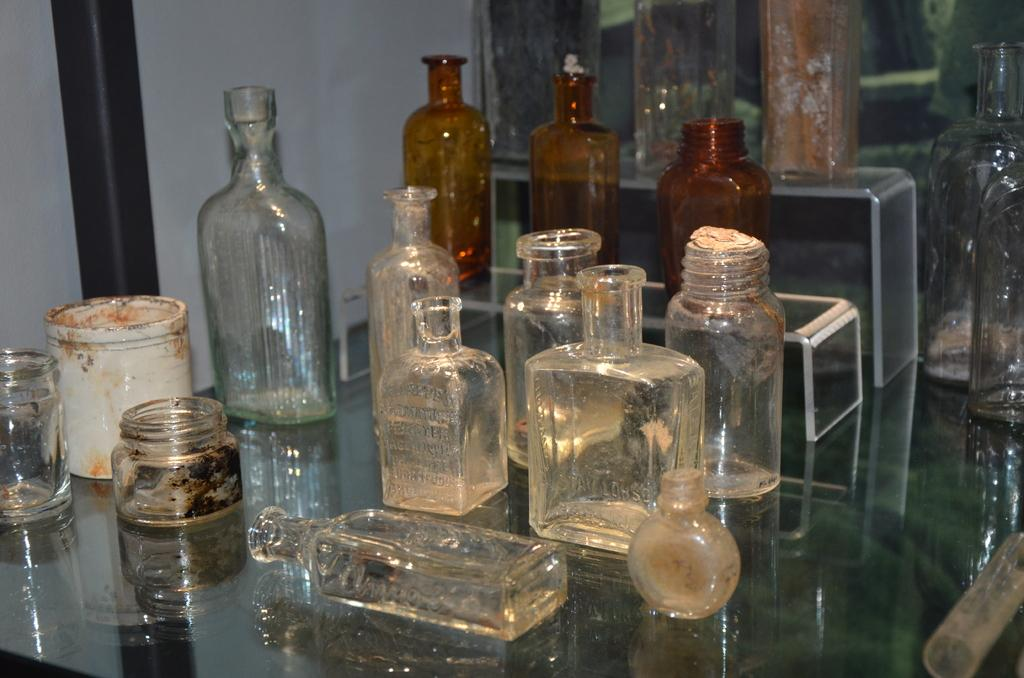What objects are made of glass in the image? There are glass bottles in the image. How do the glass bottles differ from one another? The glass bottles are of different types. Where are the glass bottles located in the image? The glass bottles are placed on a table. What type of ear can be seen on the glass bottles in the image? There are no ears present on the glass bottles in the image. 